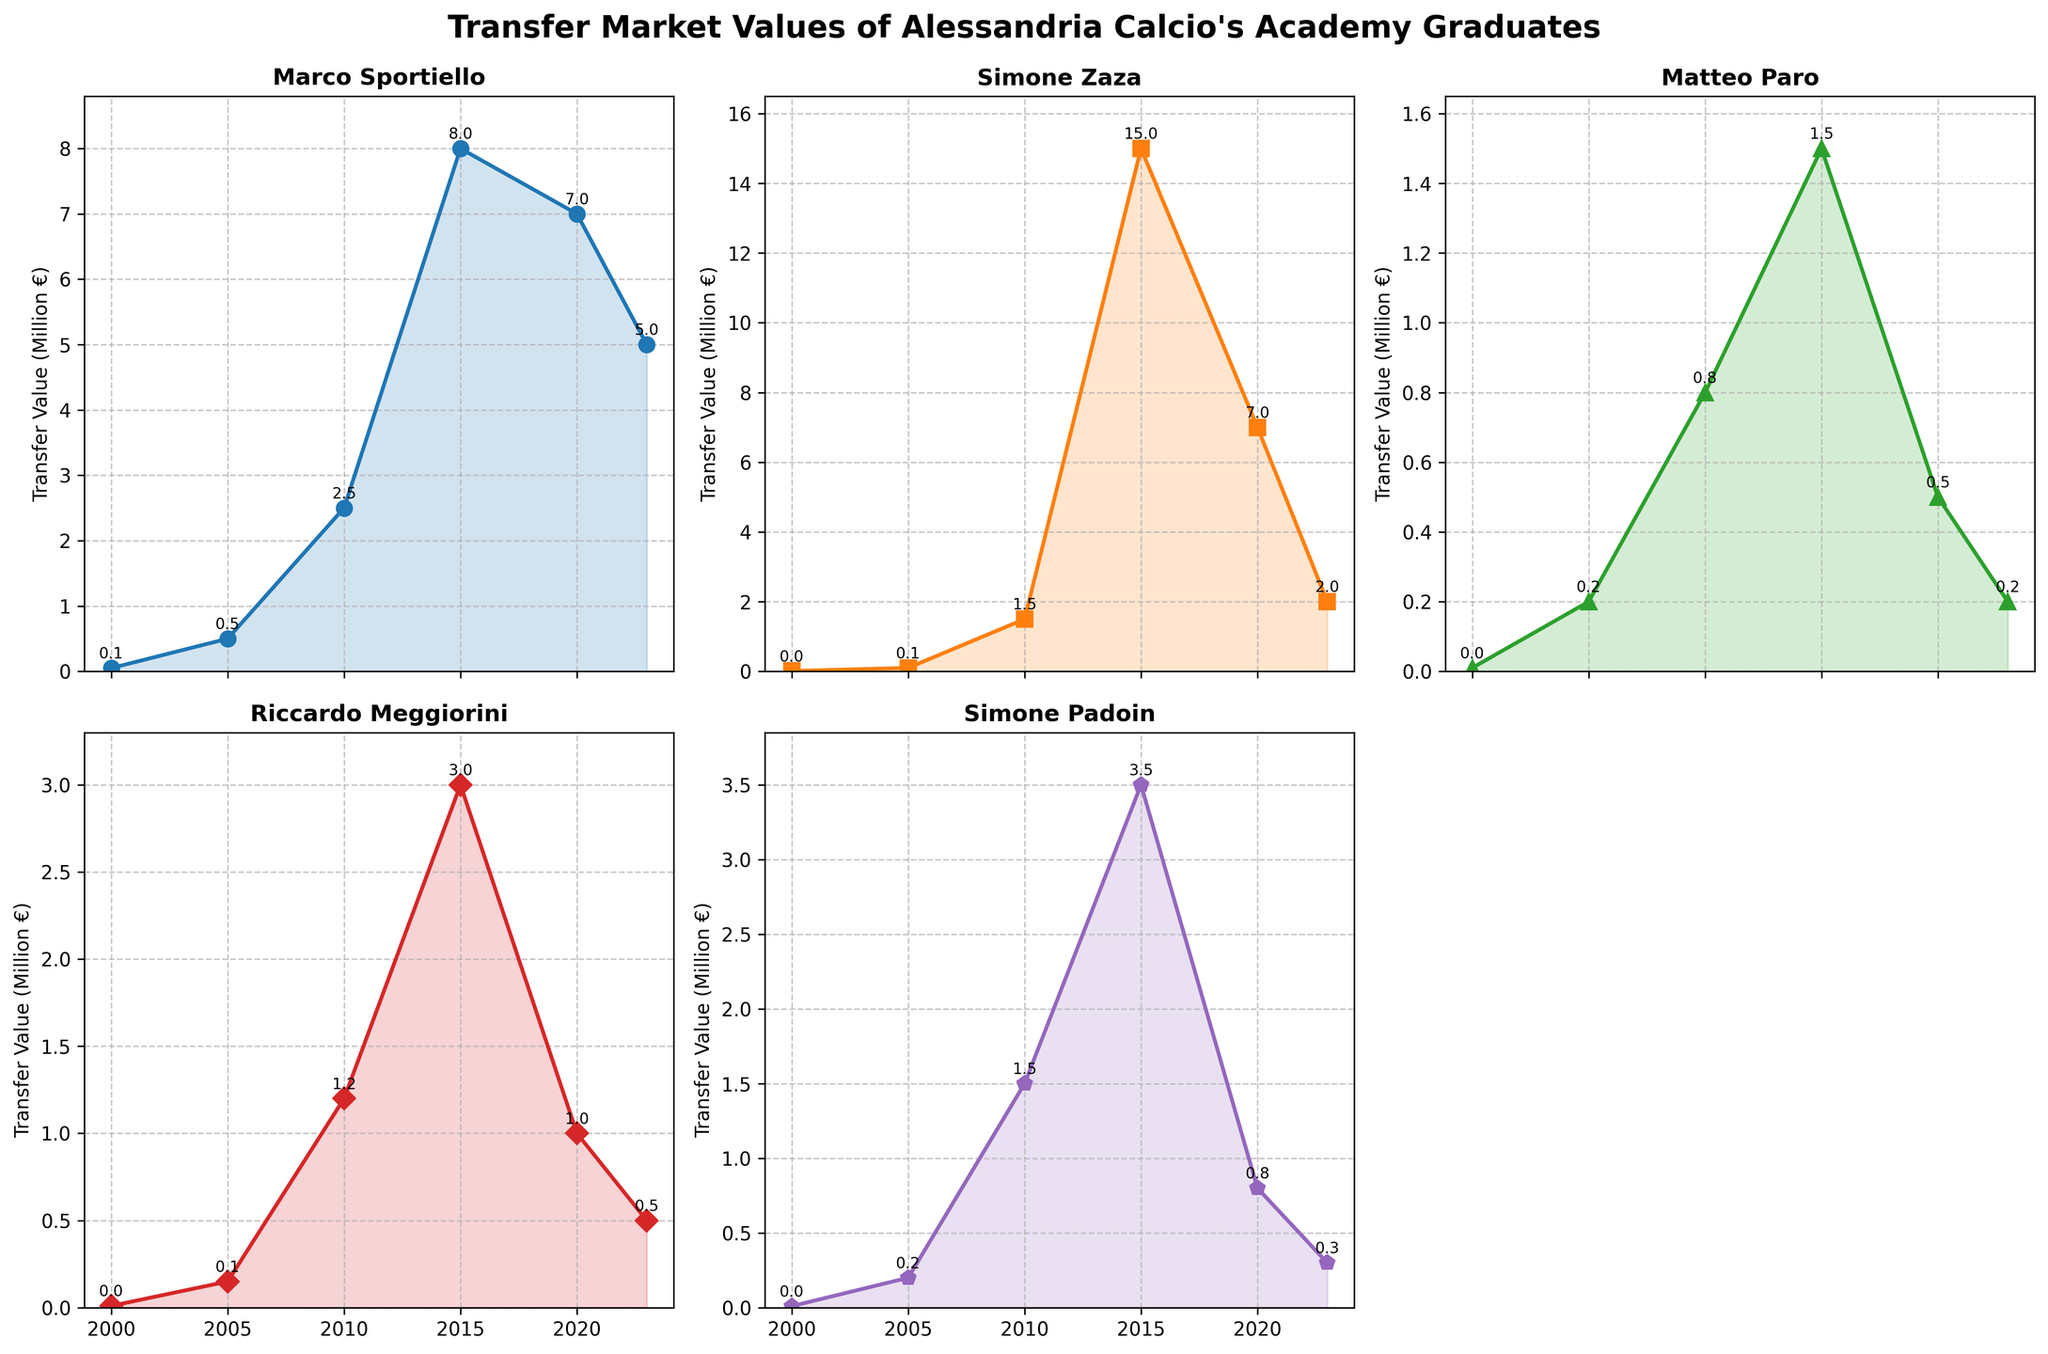How many players are shown in the figure? The figure has subplots for 5 different players: Marco Sportiello, Simone Zaza, Matteo Paro, Riccardo Meggiorini, and Simone Padoin.
Answer: 5 What is the highest transfer market value reached by any player in the figure? Which player achieved it? We need to look at the peak values in the individual player subplots. Simone Zaza's value in 2015 reaches 15 million €, which is the highest of all the players.
Answer: 15 million €, Simone Zaza During which year did Matteo Paro's transfer market value peak? By examining Matteo Paro's subplot, we see that his transfer value peaks at 2.5 million € in the year 2010.
Answer: 2010 What is the trend of Simone Padoin's transfer market value from 2000 to 2023? Simone Padoin’s transfer market value increases from 0.01 million € in 2000, peaks at 3.5 million € in 2015, and then decreases to 0.3 million € by 2023.
Answer: Increasing, peaking in 2015, then decreasing How many times did Riccardo Meggiorini's transfer market value change direction (increase to decrease or decrease to increase)? Riccardo Meggiorini's value changes direction four times: it increases from 2000 to 2010, decreases from 2010 to 2023, and these periods contain three changes.
Answer: 4 times Which player had the most stable transfer market value over the observed years? Among all the subplots, Matteo Paro's subplot shows the least fluctuation in value, making his market value the most stable over the observed period.
Answer: Matteo Paro How did Marco Sportiello's transfer value in 2023 compare to his value in 2015? In 2023, Marco Sportiello's transfer market value is 5 million €, while it was 8 million € in 2015, indicating a decrease.
Answer: Decreased What was the combined transfer market value of all players in 2010? The transfer values in 2010 are Marco Sportiello (2.5 million €), Simone Zaza (1.5 million €), Matteo Paro (0.8 million €), Riccardo Meggiorini (1.2 million €), and Simone Padoin (1.5 million €). Summing these up: 2.5 + 1.5 + 0.8 + 1.2 + 1.5 = 7.5 million €.
Answer: 7.5 million € Who had the highest transfer market value in 2005, and what was it? In 2005, Marco Sportiello had the highest market value of 0.5 million €.
Answer: Marco Sportiello, 0.5 million € Which player showed the most drastic drop in market value from their peak value to 2023? Simone Zaza's value dropped from 15 million € in 2015 to 2 million € in 2023, a decrease of 13 million €, the largest drop among the players.
Answer: Simone Zaza 